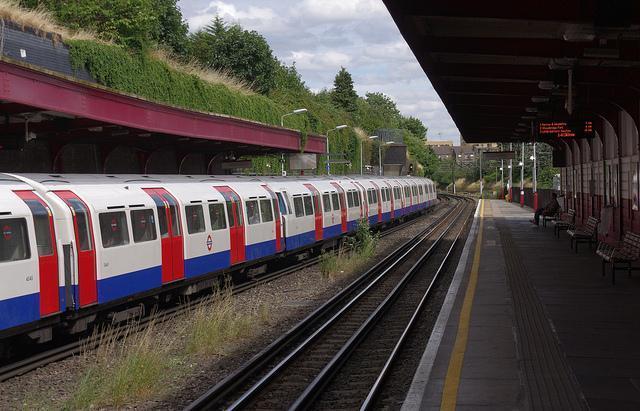How many people are around?
Give a very brief answer. 0. 